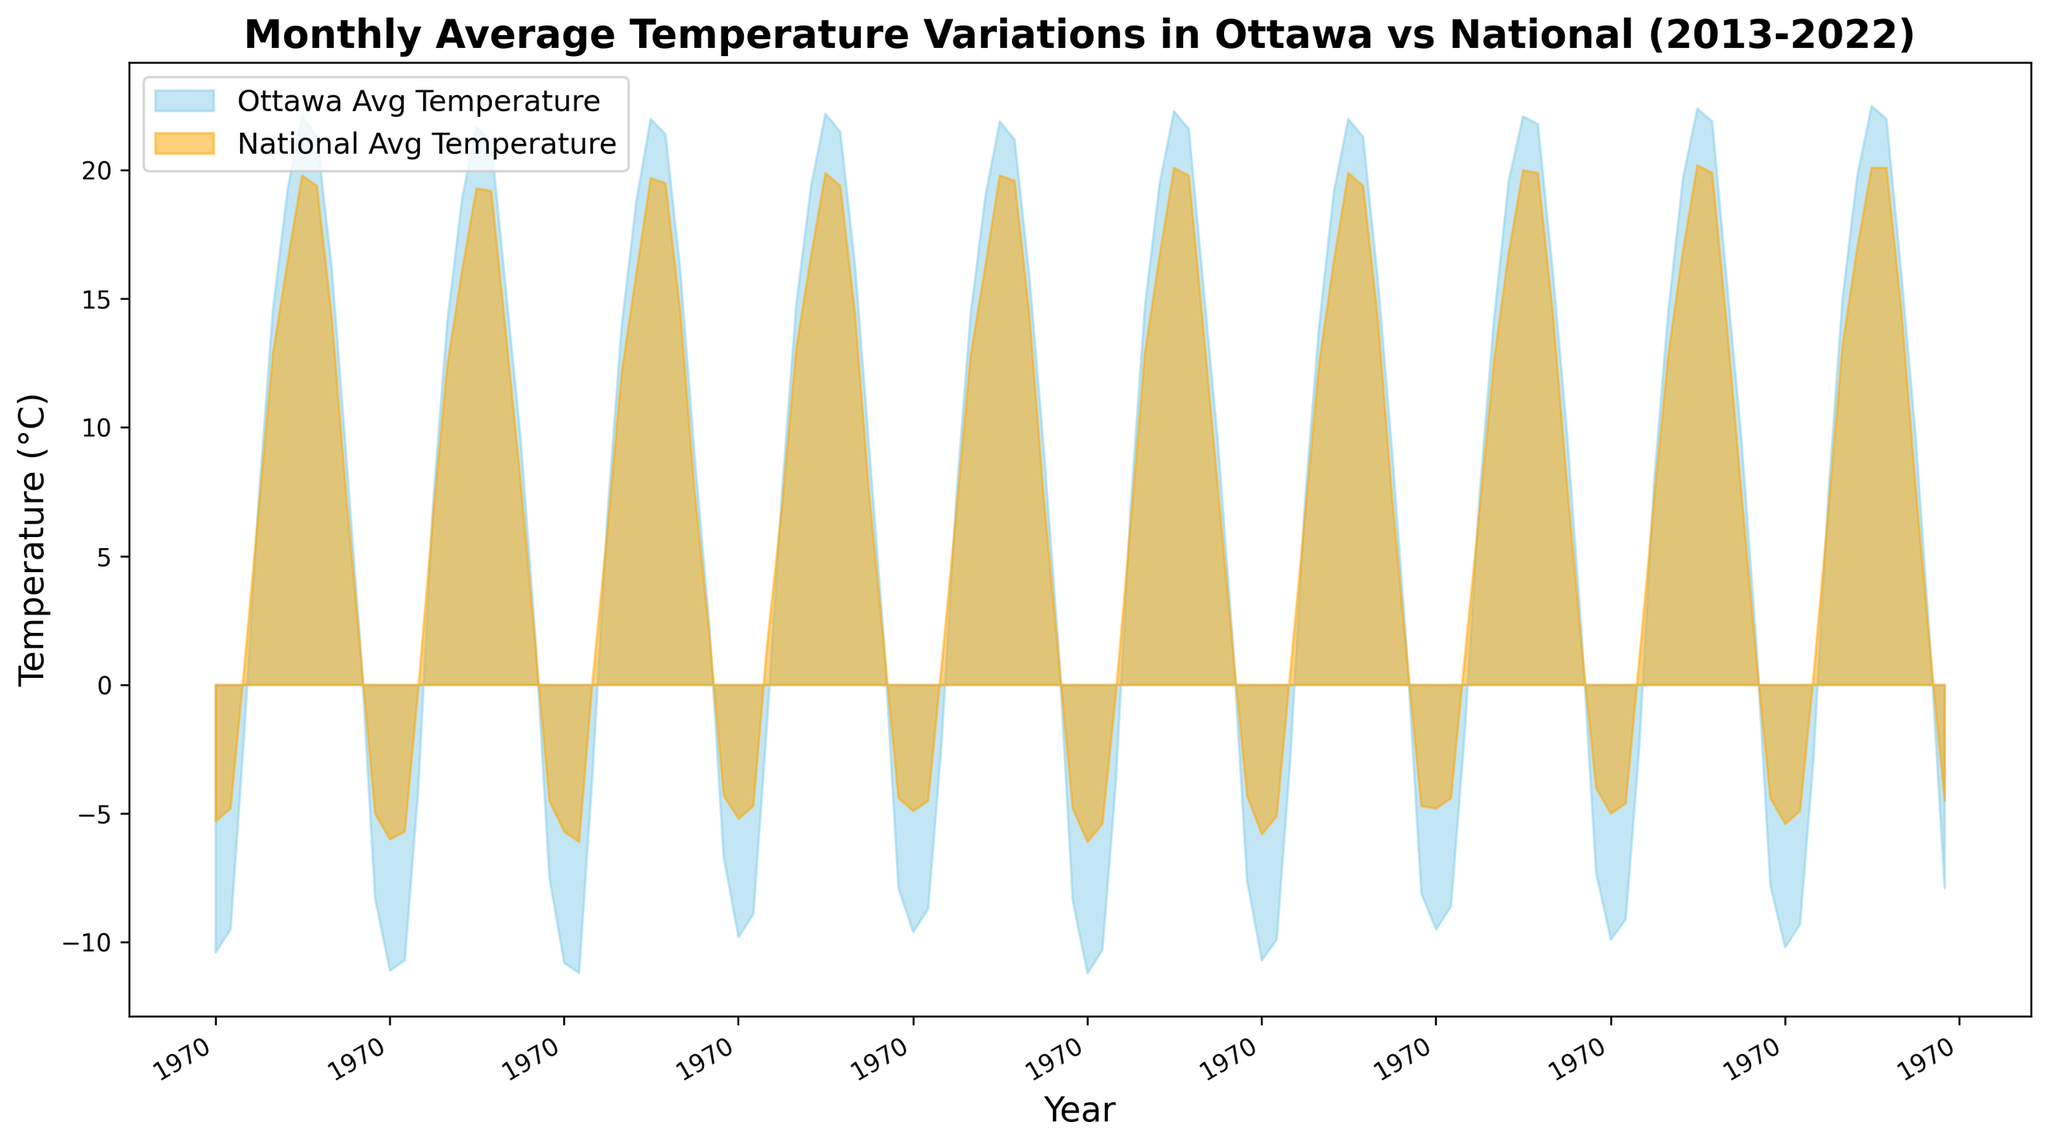What month and year had the highest average temperature in Ottawa? To find this, look for the peak of the blue area on the chart. The highest point typically indicates the month with the highest average temperature.
Answer: July 2022 What is the difference between Ottawa's and the national average temperature in Jan 2019? Determine the values for Ottawa and national average temperatures for Jan 2019 shown in the chart. Subtract the national average temperature from Ottawa's average temperature. The chart would show Ottawa at -10.7°C and national average -5.8°C. Compute -10.7 - (-5.8).
Answer: -4.9°C During which months and years were Ottawa's average temperatures consistently above the national average? Look for periods where the blue area (Ottawa) is entirely above the orange area (national). Clearly identify months and years where this happens in the chart.
Answer: March 2016, April 2016, and March 2020 What visual difference indicates higher average temperatures between Ottawa and the national average? Compare the area covered by blue (Ottawa) and orange (national). When blue is above orange, Ottawa's temperature is higher. The extent of the gap visually shows the difference in degrees.
Answer: Ottawa's temperatures are higher when the blue area is above the orange area How did Ottawa's average temperature in December compare to the national average over these years? Each December, track the trend of the blue area representing Ottawa's temperatures compared to the orange area for national temperatures. Notice the consistency or changes over the years.
Answer: Ottawa's temperature generally stayed below the national average in December When was the largest discrepancy between Ottawa and the national average temperature observed? Identify the month and year where the gap between the blue area (Ottawa) and orange area (national) was the widest. Check both directions: Ottawa much colder or much warmer.
Answer: January 2015 What was Ottawa's trend in average temperatures over the years compared to the national average during summer months (June, July, August)? Observe the blue and orange areas during June, July, and August over the years. Analyze if both trend similarly or any distinct patterns emerge.
Answer: Ottawa and the national temperatures trend similarly with Ottawa slightly higher In which year did the January temperatures show an abrupt change, either increasing or decreasing significantly compared to the previous year? Spot shifts in the height of the blue area for January from one year to the next to identify where a steep rise or fall is apparent.
Answer: January 2016 In which months did Ottawa's average temperature align most closely with the national average? Identify months where the blue and orange areas overlap or are very close to each other. Analyze the positions of both lines over the dataset.
Answer: November 2020 